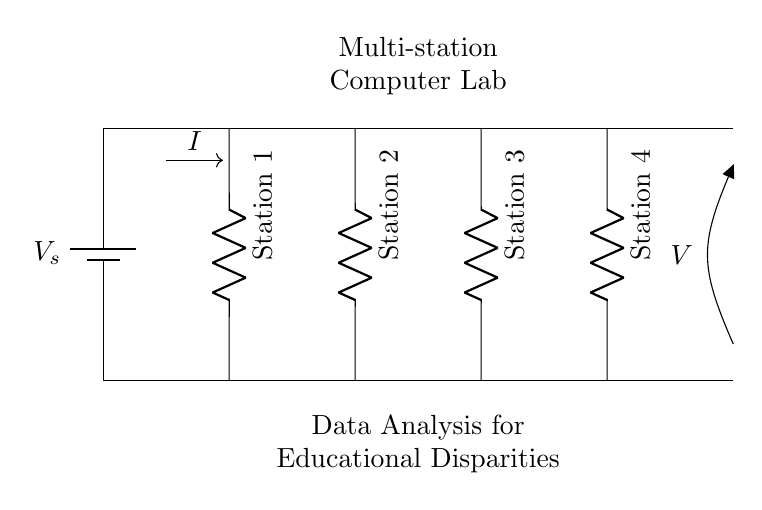What is the type of circuit depicted? The circuit is a parallel circuit as multiple components (stations) are connected in parallel to the same voltage source.
Answer: Parallel How many computer stations are present? There are four computer stations represented in the circuit diagram, as indicated by the four resistors labeled Station 1 through Station 4.
Answer: Four What is the voltage supplied by the battery? The battery notation is marked as \(V_s\) but no specific value is given in the diagram, therefore we refer to it as the supplied voltage.
Answer: V_s What happens to the current as it splits among the stations? In a parallel circuit, the total current is divided among the branches. Each branch (station) will have its own current flow based on the resistance of that specific station.
Answer: It divides What can be inferred about the resistance of each station if they are equal? If all computer stations (resistors) are equal, each one will carry the same current and the total resistance in the circuit can be calculated using the formula for parallel resistors. The effective resistance will be lower than the resistance of each individual station.
Answer: Total resistance is less What is the direction of the current flow in the circuit? The current flows from the positive terminal of the battery downward through the resistors and returns to the negative terminal, following the designated path illustrated by the arrows.
Answer: Downward Will the voltage across each computer station be the same? Yes, in a parallel circuit, the voltage across all parallel components is the same and equals the supplied voltage from the battery.
Answer: Yes 